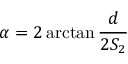<formula> <loc_0><loc_0><loc_500><loc_500>\alpha = 2 \arctan { \frac { d } { 2 S _ { 2 } } }</formula> 